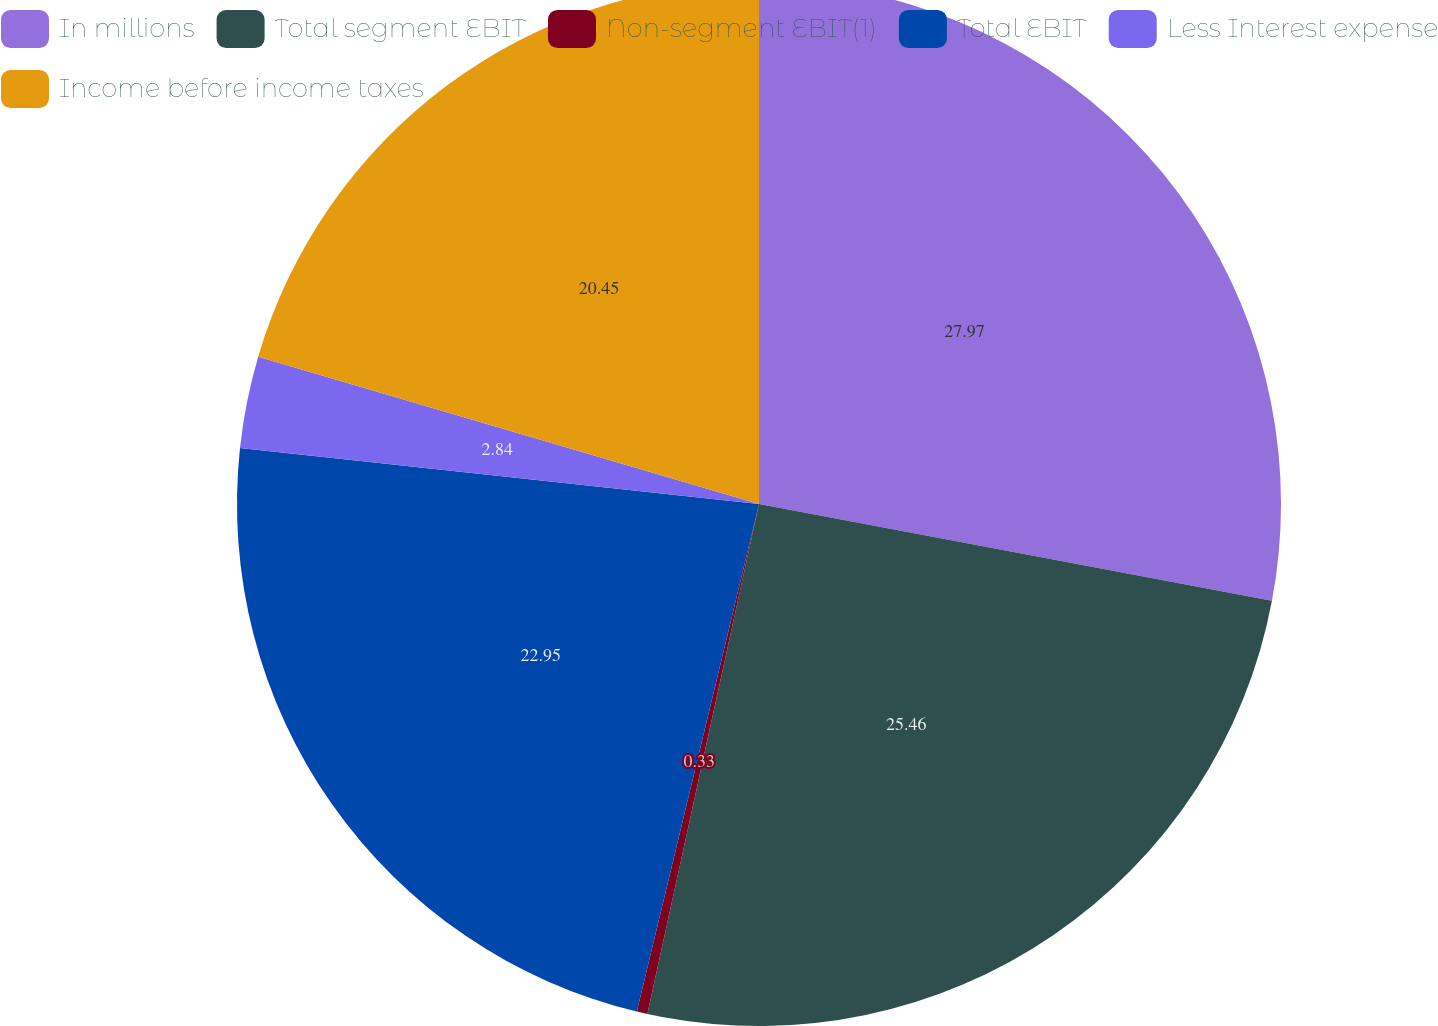Convert chart. <chart><loc_0><loc_0><loc_500><loc_500><pie_chart><fcel>In millions<fcel>Total segment EBIT<fcel>Non-segment EBIT(1)<fcel>Total EBIT<fcel>Less Interest expense<fcel>Income before income taxes<nl><fcel>27.97%<fcel>25.46%<fcel>0.33%<fcel>22.95%<fcel>2.84%<fcel>20.45%<nl></chart> 